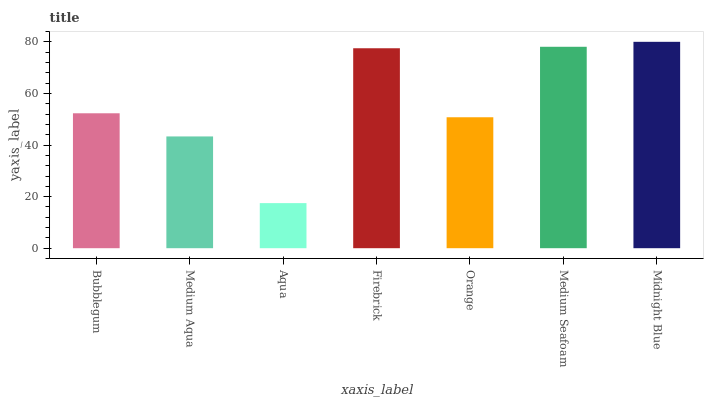Is Medium Aqua the minimum?
Answer yes or no. No. Is Medium Aqua the maximum?
Answer yes or no. No. Is Bubblegum greater than Medium Aqua?
Answer yes or no. Yes. Is Medium Aqua less than Bubblegum?
Answer yes or no. Yes. Is Medium Aqua greater than Bubblegum?
Answer yes or no. No. Is Bubblegum less than Medium Aqua?
Answer yes or no. No. Is Bubblegum the high median?
Answer yes or no. Yes. Is Bubblegum the low median?
Answer yes or no. Yes. Is Medium Aqua the high median?
Answer yes or no. No. Is Firebrick the low median?
Answer yes or no. No. 